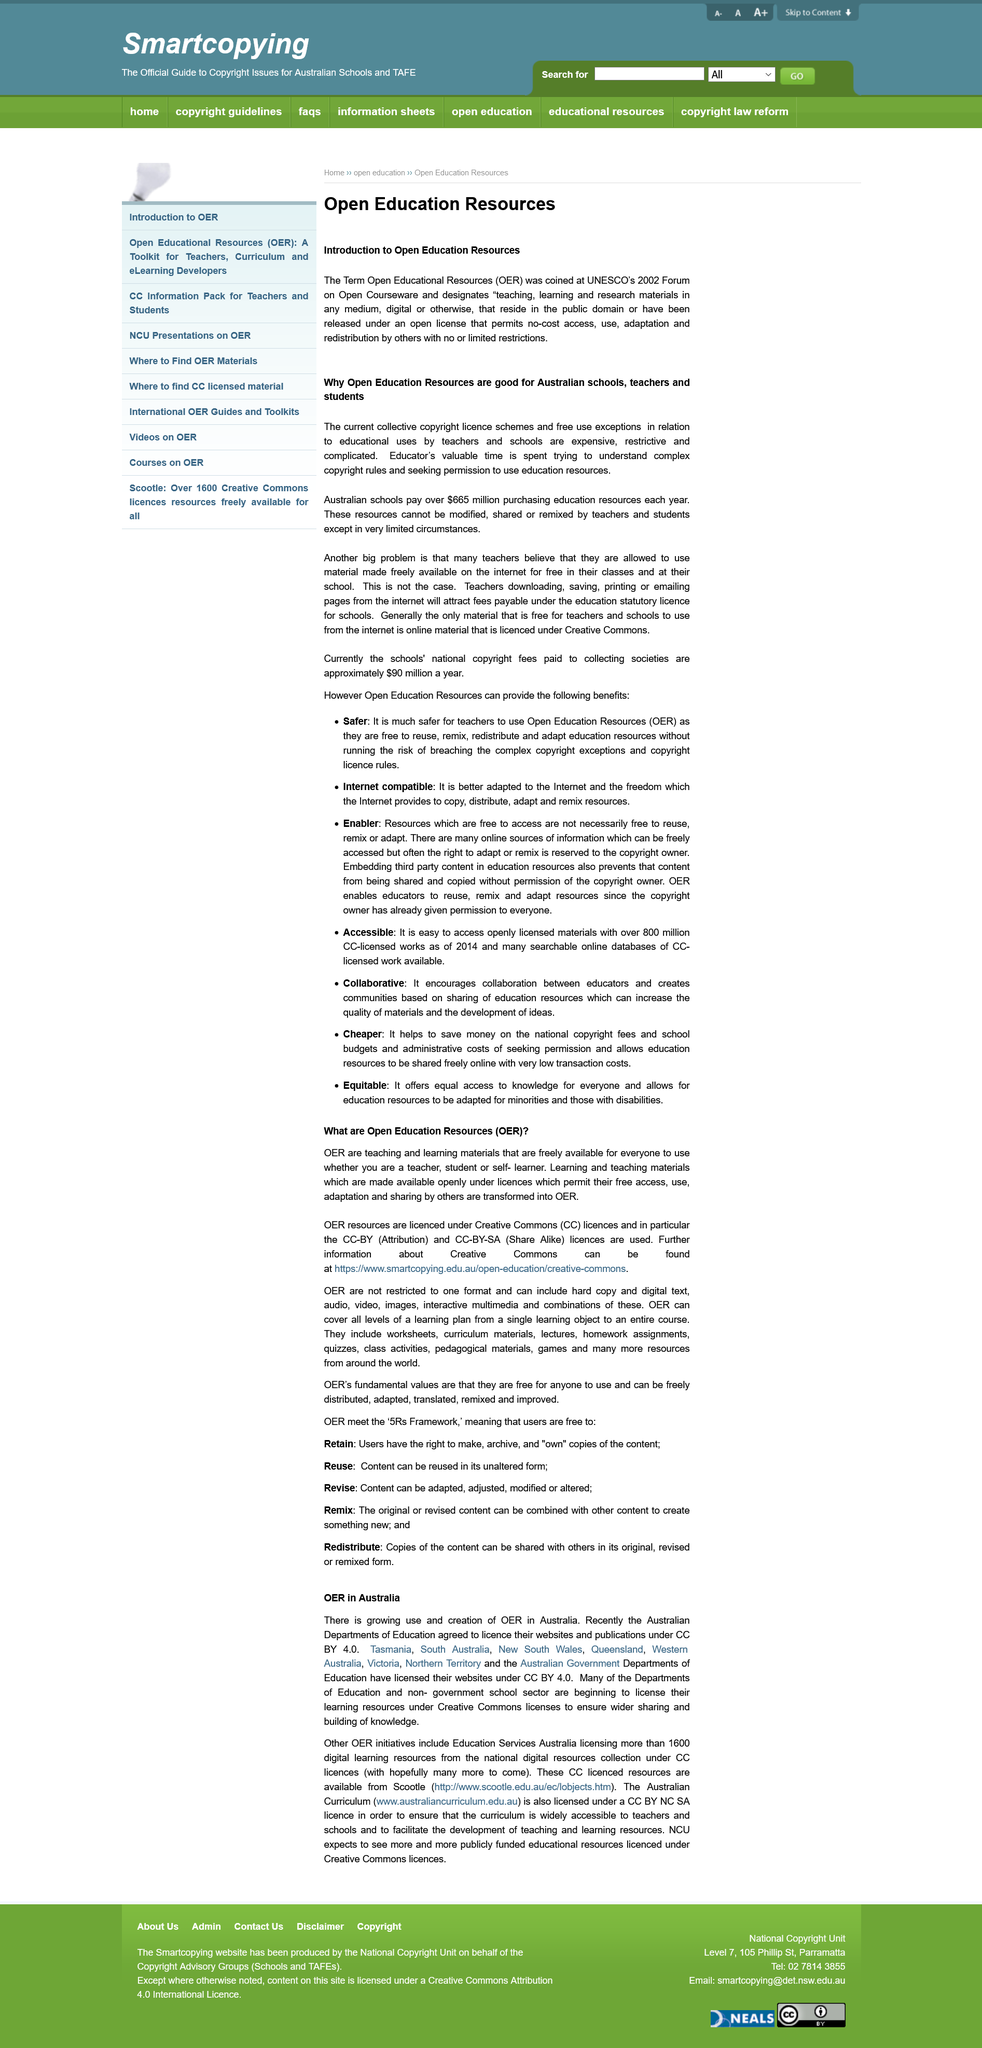Outline some significant characteristics in this image. The Australian Departments of Education have agreed to license their websites under a Creative Commons Attribution 4.0 license. Open education resources are shortened as OER. A growing number of organizations are beginning to license their learning resources under Creative Commons licenses in order to facilitate wider sharing and the building of knowledge, particularly in the Departments of Education and the non-government school sector. The open license has either a cost or is no-cost. It is no-cost. The term "Open Educational Resources" was first coined in 2002. 